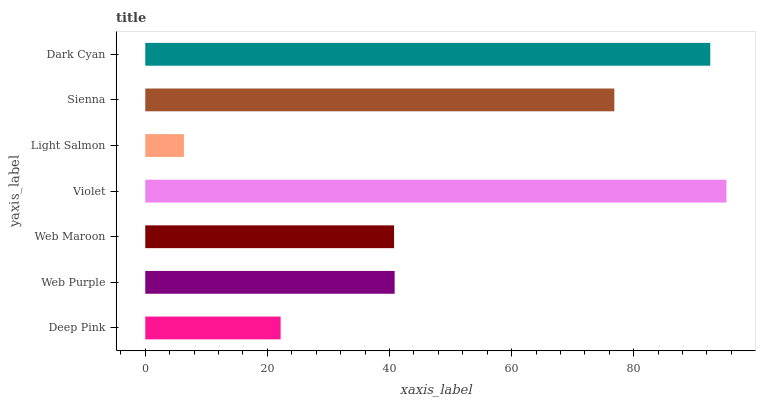Is Light Salmon the minimum?
Answer yes or no. Yes. Is Violet the maximum?
Answer yes or no. Yes. Is Web Purple the minimum?
Answer yes or no. No. Is Web Purple the maximum?
Answer yes or no. No. Is Web Purple greater than Deep Pink?
Answer yes or no. Yes. Is Deep Pink less than Web Purple?
Answer yes or no. Yes. Is Deep Pink greater than Web Purple?
Answer yes or no. No. Is Web Purple less than Deep Pink?
Answer yes or no. No. Is Web Purple the high median?
Answer yes or no. Yes. Is Web Purple the low median?
Answer yes or no. Yes. Is Violet the high median?
Answer yes or no. No. Is Sienna the low median?
Answer yes or no. No. 